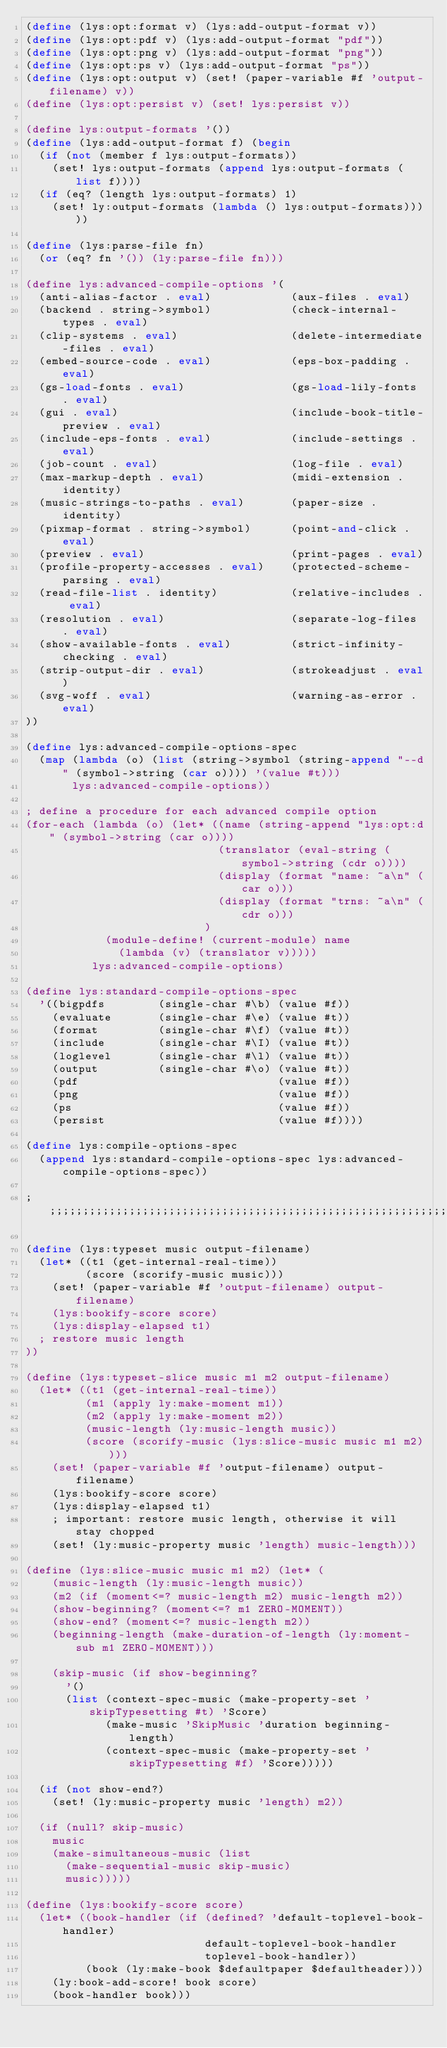Convert code to text. <code><loc_0><loc_0><loc_500><loc_500><_Scheme_>(define (lys:opt:format v) (lys:add-output-format v))
(define (lys:opt:pdf v) (lys:add-output-format "pdf"))
(define (lys:opt:png v) (lys:add-output-format "png"))
(define (lys:opt:ps v) (lys:add-output-format "ps"))
(define (lys:opt:output v) (set! (paper-variable #f 'output-filename) v))
(define (lys:opt:persist v) (set! lys:persist v))

(define lys:output-formats '())
(define (lys:add-output-format f) (begin
  (if (not (member f lys:output-formats))
    (set! lys:output-formats (append lys:output-formats (list f))))
  (if (eq? (length lys:output-formats) 1)
    (set! ly:output-formats (lambda () lys:output-formats)))))

(define (lys:parse-file fn)
  (or (eq? fn '()) (ly:parse-file fn)))

(define lys:advanced-compile-options '(
  (anti-alias-factor . eval)            (aux-files . eval)
  (backend . string->symbol)            (check-internal-types . eval)
  (clip-systems . eval)                 (delete-intermediate-files . eval)
  (embed-source-code . eval)            (eps-box-padding . eval)
  (gs-load-fonts . eval)                (gs-load-lily-fonts . eval)
  (gui . eval)                          (include-book-title-preview . eval)
  (include-eps-fonts . eval)            (include-settings . eval)
  (job-count . eval)                    (log-file . eval)
  (max-markup-depth . eval)             (midi-extension . identity)
  (music-strings-to-paths . eval)       (paper-size . identity)
  (pixmap-format . string->symbol)      (point-and-click . eval)
  (preview . eval)                      (print-pages . eval)
  (profile-property-accesses . eval)    (protected-scheme-parsing . eval)
  (read-file-list . identity)           (relative-includes . eval)
  (resolution . eval)                   (separate-log-files . eval)
  (show-available-fonts . eval)         (strict-infinity-checking . eval)
  (strip-output-dir . eval)             (strokeadjust . eval)
  (svg-woff . eval)                     (warning-as-error . eval)
))

(define lys:advanced-compile-options-spec
  (map (lambda (o) (list (string->symbol (string-append "--d" (symbol->string (car o)))) '(value #t)))
       lys:advanced-compile-options))

; define a procedure for each advanced compile option
(for-each (lambda (o) (let* ((name (string-append "lys:opt:d" (symbol->string (car o))))
                             (translator (eval-string (symbol->string (cdr o))))
                             (display (format "name: ~a\n" (car o)))
                             (display (format "trns: ~a\n" (cdr o)))
                           )
            (module-define! (current-module) name
              (lambda (v) (translator v)))))
          lys:advanced-compile-options)

(define lys:standard-compile-options-spec
  '((bigpdfs        (single-char #\b) (value #f))
    (evaluate       (single-char #\e) (value #t))
    (format         (single-char #\f) (value #t))
    (include        (single-char #\I) (value #t))
    (loglevel       (single-char #\l) (value #t))
    (output         (single-char #\o) (value #t))
    (pdf                              (value #f))
    (png                              (value #f))
    (ps                               (value #f))
    (persist                          (value #f))))

(define lys:compile-options-spec
  (append lys:standard-compile-options-spec lys:advanced-compile-options-spec))

;;;;;;;;;;;;;;;;;;;;;;;;;;;;;;;;;;;;;;;;;;;;;;;;;;;;;;;;;;;;;;;;;;;;;;;;;;;;;;;;

(define (lys:typeset music output-filename)
  (let* ((t1 (get-internal-real-time))
         (score (scorify-music music)))
    (set! (paper-variable #f 'output-filename) output-filename)
    (lys:bookify-score score)
    (lys:display-elapsed t1)
  ; restore music length
))

(define (lys:typeset-slice music m1 m2 output-filename)
  (let* ((t1 (get-internal-real-time))
         (m1 (apply ly:make-moment m1))
         (m2 (apply ly:make-moment m2))
         (music-length (ly:music-length music))
         (score (scorify-music (lys:slice-music music m1 m2))))
    (set! (paper-variable #f 'output-filename) output-filename)
    (lys:bookify-score score)
    (lys:display-elapsed t1)
    ; important: restore music length, otherwise it will stay chopped
    (set! (ly:music-property music 'length) music-length)))

(define (lys:slice-music music m1 m2) (let* (
    (music-length (ly:music-length music))
    (m2 (if (moment<=? music-length m2) music-length m2))
    (show-beginning? (moment<=? m1 ZERO-MOMENT))
    (show-end? (moment<=? music-length m2))
    (beginning-length (make-duration-of-length (ly:moment-sub m1 ZERO-MOMENT)))

    (skip-music (if show-beginning?
      '()
      (list (context-spec-music (make-property-set 'skipTypesetting #t) 'Score)
            (make-music 'SkipMusic 'duration beginning-length)
            (context-spec-music (make-property-set 'skipTypesetting #f) 'Score)))))

  (if (not show-end?)
    (set! (ly:music-property music 'length) m2))

  (if (null? skip-music)
    music
    (make-simultaneous-music (list
      (make-sequential-music skip-music)
      music)))))
  
(define (lys:bookify-score score)
  (let* ((book-handler (if (defined? 'default-toplevel-book-handler)
                           default-toplevel-book-handler
                           toplevel-book-handler))
         (book (ly:make-book $defaultpaper $defaultheader)))
    (ly:book-add-score! book score)
    (book-handler book)))
         
</code> 